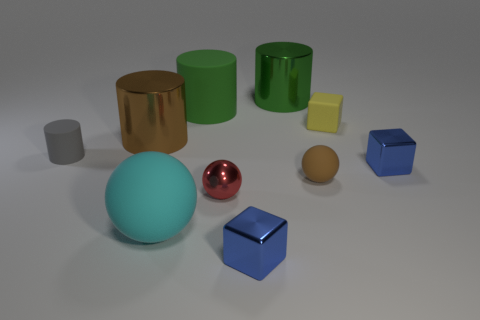There is a block that is in front of the big brown shiny object and on the right side of the big green shiny object; what material is it?
Ensure brevity in your answer.  Metal. There is a cube behind the gray rubber object; is it the same size as the red shiny object?
Provide a short and direct response. Yes. The red shiny thing is what shape?
Provide a succinct answer. Sphere. What number of metal objects are the same shape as the gray matte object?
Make the answer very short. 2. How many things are to the right of the small red sphere and in front of the red thing?
Provide a short and direct response. 1. What color is the tiny shiny sphere?
Make the answer very short. Red. Are there any big red blocks made of the same material as the gray cylinder?
Provide a succinct answer. No. There is a tiny blue shiny cube that is left of the small rubber object that is behind the tiny gray thing; are there any small red metallic spheres to the right of it?
Provide a succinct answer. No. There is a big cyan matte thing; are there any brown shiny things in front of it?
Keep it short and to the point. No. Are there any large metallic things that have the same color as the small shiny ball?
Offer a very short reply. No. 